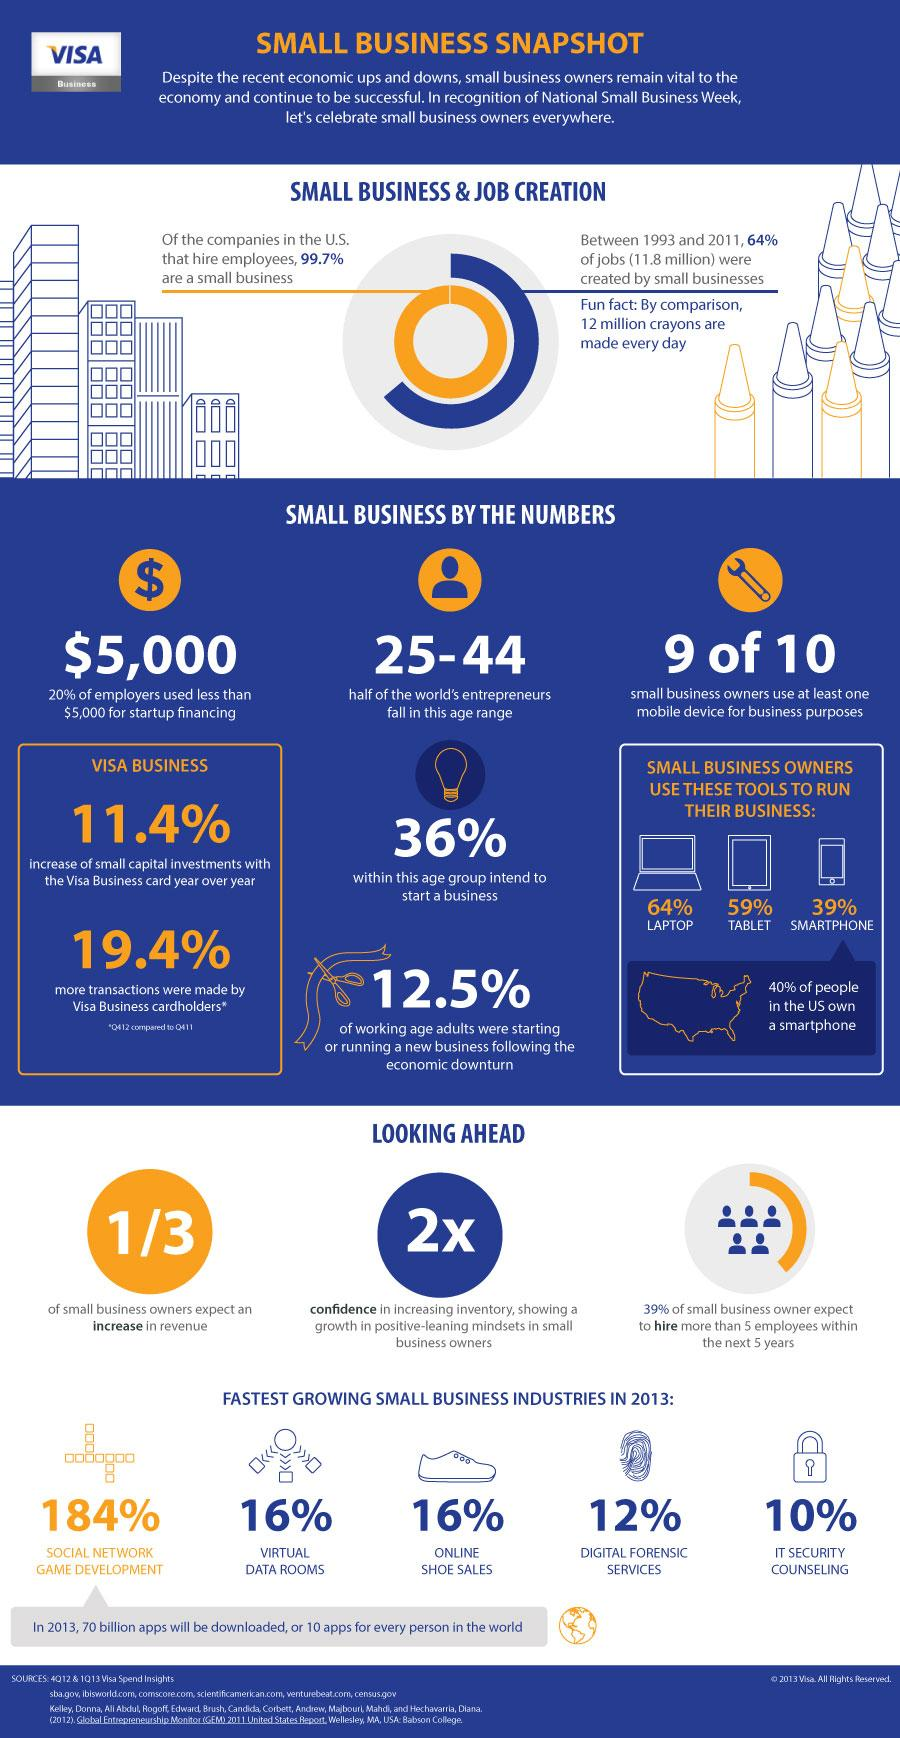List a handful of essential elements in this visual. The growth of online shoe sales was 16%. According to the data, a staggering 87.5% of working-age adults have not yet started a new business. In the US town, 60% of the population did not own a smartphone. The digital forensic services have experienced a growth of 12% over the past year. The percentage growth of the virtual data room business is 16%. 